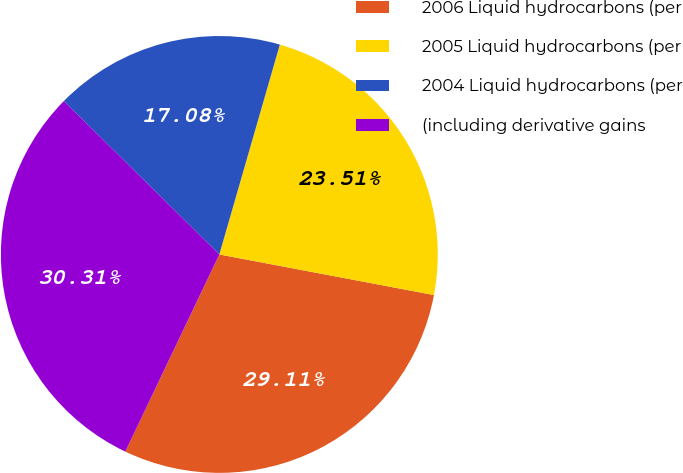Convert chart to OTSL. <chart><loc_0><loc_0><loc_500><loc_500><pie_chart><fcel>2006 Liquid hydrocarbons (per<fcel>2005 Liquid hydrocarbons (per<fcel>2004 Liquid hydrocarbons (per<fcel>(including derivative gains<nl><fcel>29.11%<fcel>23.51%<fcel>17.08%<fcel>30.31%<nl></chart> 